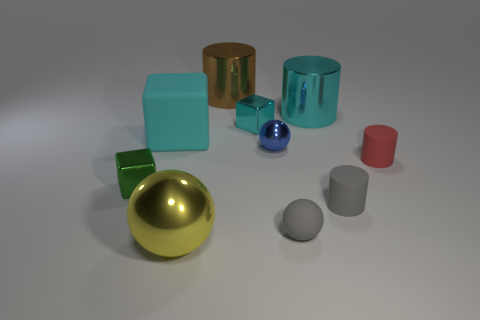Subtract 2 cylinders. How many cylinders are left? 2 Subtract all cyan cylinders. How many cylinders are left? 3 Subtract all purple cylinders. Subtract all red cubes. How many cylinders are left? 4 Subtract all balls. How many objects are left? 7 Subtract 2 cyan blocks. How many objects are left? 8 Subtract all tiny cyan metal cylinders. Subtract all tiny gray cylinders. How many objects are left? 9 Add 3 small blue metallic objects. How many small blue metallic objects are left? 4 Add 6 gray shiny things. How many gray shiny things exist? 6 